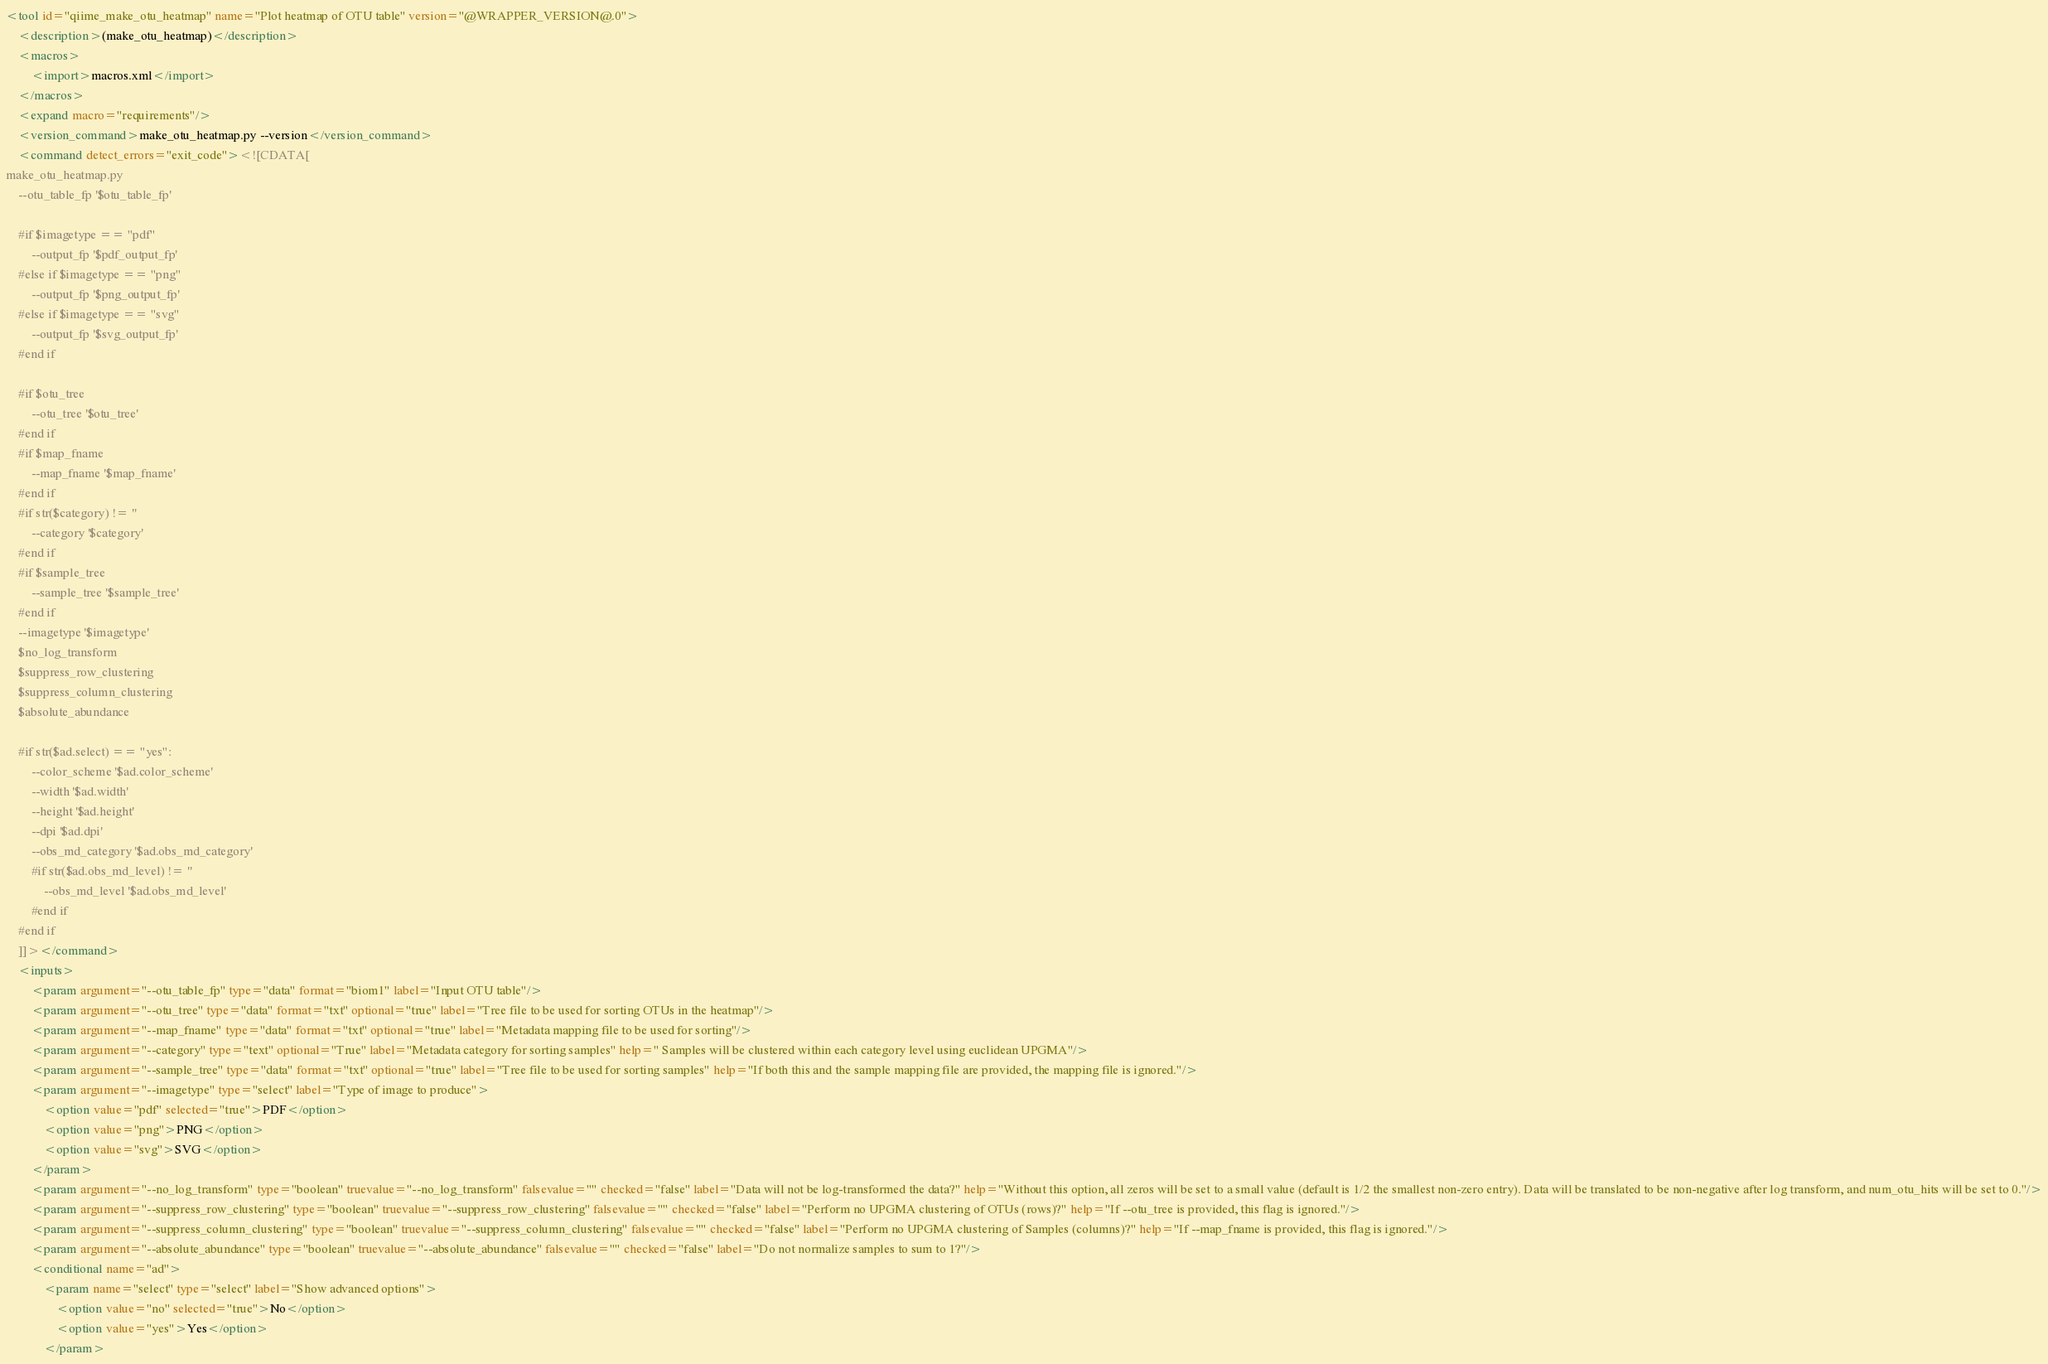<code> <loc_0><loc_0><loc_500><loc_500><_XML_><tool id="qiime_make_otu_heatmap" name="Plot heatmap of OTU table" version="@WRAPPER_VERSION@.0">
    <description>(make_otu_heatmap)</description>
    <macros>
        <import>macros.xml</import>
    </macros>
    <expand macro="requirements"/>
    <version_command>make_otu_heatmap.py --version</version_command>
    <command detect_errors="exit_code"><![CDATA[
make_otu_heatmap.py
    --otu_table_fp '$otu_table_fp'

    #if $imagetype == "pdf"
        --output_fp '$pdf_output_fp'
    #else if $imagetype == "png"
        --output_fp '$png_output_fp'
    #else if $imagetype == "svg"
        --output_fp '$svg_output_fp'
    #end if

    #if $otu_tree
        --otu_tree '$otu_tree'
    #end if
    #if $map_fname
        --map_fname '$map_fname'
    #end if
    #if str($category) != ''
        --category '$category'
    #end if
    #if $sample_tree
        --sample_tree '$sample_tree'
    #end if
    --imagetype '$imagetype'
    $no_log_transform
    $suppress_row_clustering
    $suppress_column_clustering
    $absolute_abundance

    #if str($ad.select) == "yes":
        --color_scheme '$ad.color_scheme'
        --width '$ad.width'
        --height '$ad.height'
        --dpi '$ad.dpi'
        --obs_md_category '$ad.obs_md_category'
        #if str($ad.obs_md_level) != ''
            --obs_md_level '$ad.obs_md_level'
        #end if
    #end if
    ]]></command>
    <inputs>
        <param argument="--otu_table_fp" type="data" format="biom1" label="Input OTU table"/>
        <param argument="--otu_tree" type="data" format="txt" optional="true" label="Tree file to be used for sorting OTUs in the heatmap"/>
        <param argument="--map_fname" type="data" format="txt" optional="true" label="Metadata mapping file to be used for sorting"/>
        <param argument="--category" type="text" optional="True" label="Metadata category for sorting samples" help=" Samples will be clustered within each category level using euclidean UPGMA"/>
        <param argument="--sample_tree" type="data" format="txt" optional="true" label="Tree file to be used for sorting samples" help="If both this and the sample mapping file are provided, the mapping file is ignored."/>
        <param argument="--imagetype" type="select" label="Type of image to produce">
            <option value="pdf" selected="true">PDF</option>
            <option value="png">PNG</option>
            <option value="svg">SVG</option>
        </param>
        <param argument="--no_log_transform" type="boolean" truevalue="--no_log_transform" falsevalue="" checked="false" label="Data will not be log-transformed the data?" help="Without this option, all zeros will be set to a small value (default is 1/2 the smallest non-zero entry). Data will be translated to be non-negative after log transform, and num_otu_hits will be set to 0."/>
        <param argument="--suppress_row_clustering" type="boolean" truevalue="--suppress_row_clustering" falsevalue="" checked="false" label="Perform no UPGMA clustering of OTUs (rows)?" help="If --otu_tree is provided, this flag is ignored."/>
        <param argument="--suppress_column_clustering" type="boolean" truevalue="--suppress_column_clustering" falsevalue="" checked="false" label="Perform no UPGMA clustering of Samples (columns)?" help="If --map_fname is provided, this flag is ignored."/>
        <param argument="--absolute_abundance" type="boolean" truevalue="--absolute_abundance" falsevalue="" checked="false" label="Do not normalize samples to sum to 1?"/>
        <conditional name="ad">
            <param name="select" type="select" label="Show advanced options">
                <option value="no" selected="true">No</option>
                <option value="yes">Yes</option>
            </param></code> 